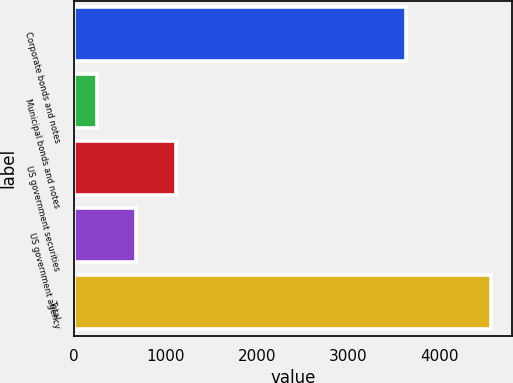Convert chart. <chart><loc_0><loc_0><loc_500><loc_500><bar_chart><fcel>Corporate bonds and notes<fcel>Municipal bonds and notes<fcel>US government securities<fcel>US government agency<fcel>Total<nl><fcel>3635<fcel>247<fcel>1109.4<fcel>678.2<fcel>4559<nl></chart> 